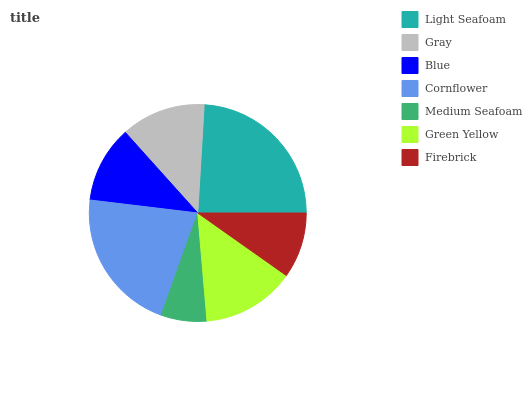Is Medium Seafoam the minimum?
Answer yes or no. Yes. Is Light Seafoam the maximum?
Answer yes or no. Yes. Is Gray the minimum?
Answer yes or no. No. Is Gray the maximum?
Answer yes or no. No. Is Light Seafoam greater than Gray?
Answer yes or no. Yes. Is Gray less than Light Seafoam?
Answer yes or no. Yes. Is Gray greater than Light Seafoam?
Answer yes or no. No. Is Light Seafoam less than Gray?
Answer yes or no. No. Is Gray the high median?
Answer yes or no. Yes. Is Gray the low median?
Answer yes or no. Yes. Is Firebrick the high median?
Answer yes or no. No. Is Medium Seafoam the low median?
Answer yes or no. No. 